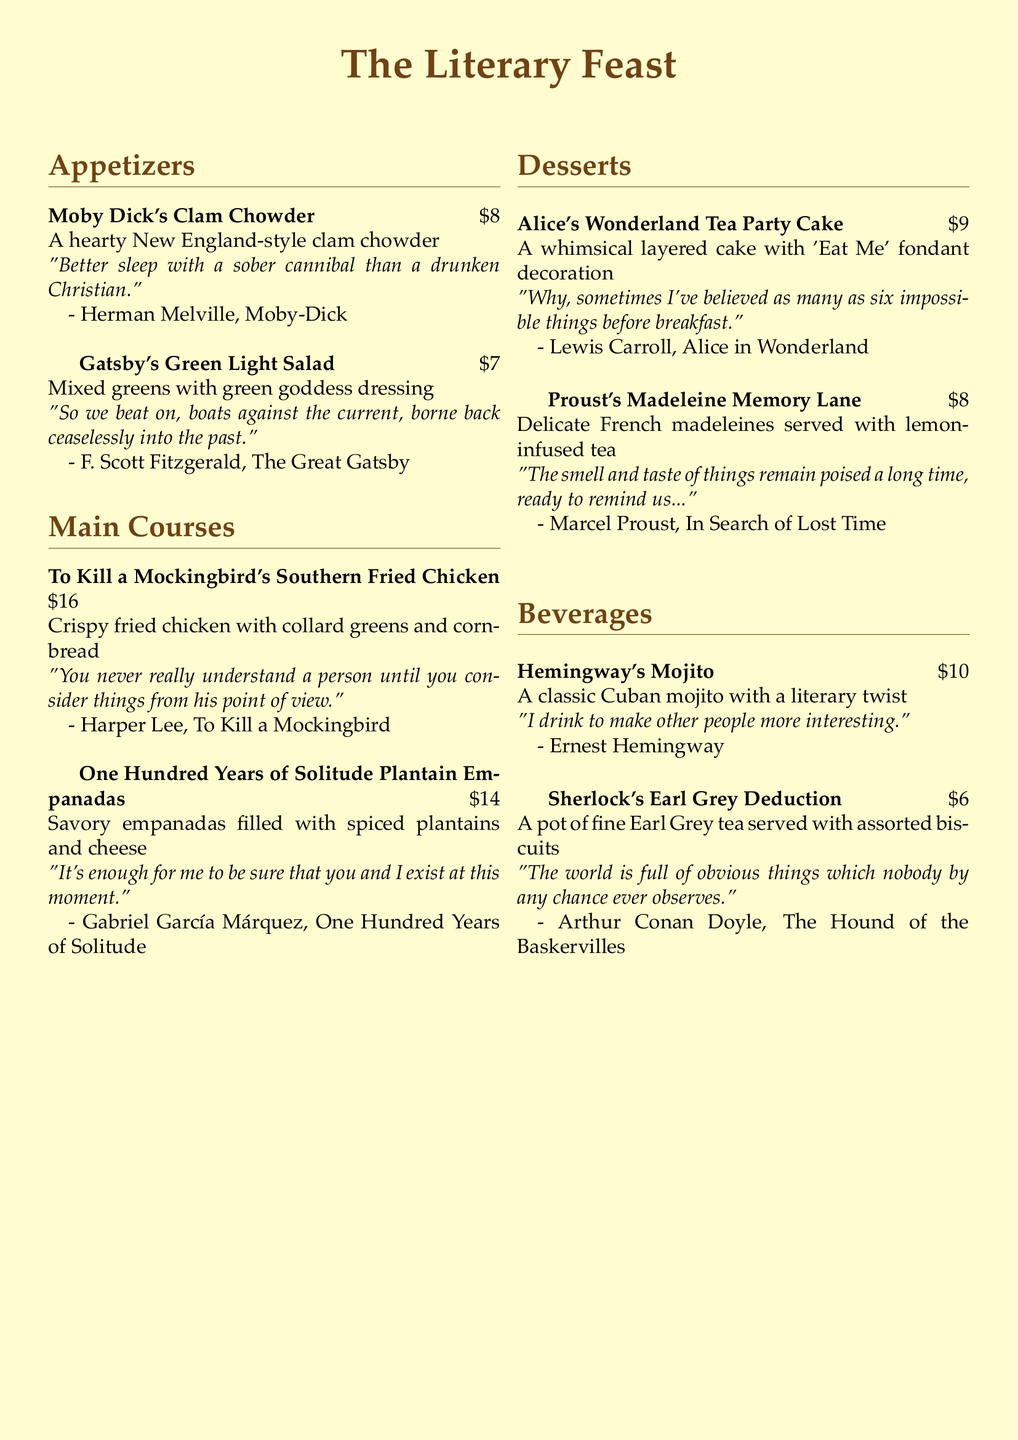What is the title of the menu? The title of the menu is presented at the top of the document.
Answer: The Literary Feast What is the price of Gatsby's Green Light Salad? The price of Gatsby's Green Light Salad is listed next to the dish in the document.
Answer: $7 Which literary work inspired the dish featuring crispy fried chicken? The dish inspired by crispy fried chicken is named after a specific literary work.
Answer: To Kill a Mockingbird What type of beverage is Hemingway's Mojito? The type of beverage is a classic cocktail mentioned in the beverages section.
Answer: Mojito How much does Alice's Wonderland Tea Party Cake cost? The cost of Alice's Wonderland Tea Party Cake is provided alongside its description.
Answer: $9 What is included in the Southern Fried Chicken dish? The description of the dish includes details about its accompaniments.
Answer: collard greens and cornbread Which author wrote the quote about believing six impossible things? The quote is attributed to a specific author in the desserts section.
Answer: Lewis Carroll How many appetizers are listed on the menu? The number of appetizers can be calculated based on the section titles and the dishes listed.
Answer: 2 What type of tea is served with Sherlock's Earl Grey Deduction? The type of tea served with the dish is stated in its description.
Answer: Earl Grey tea 